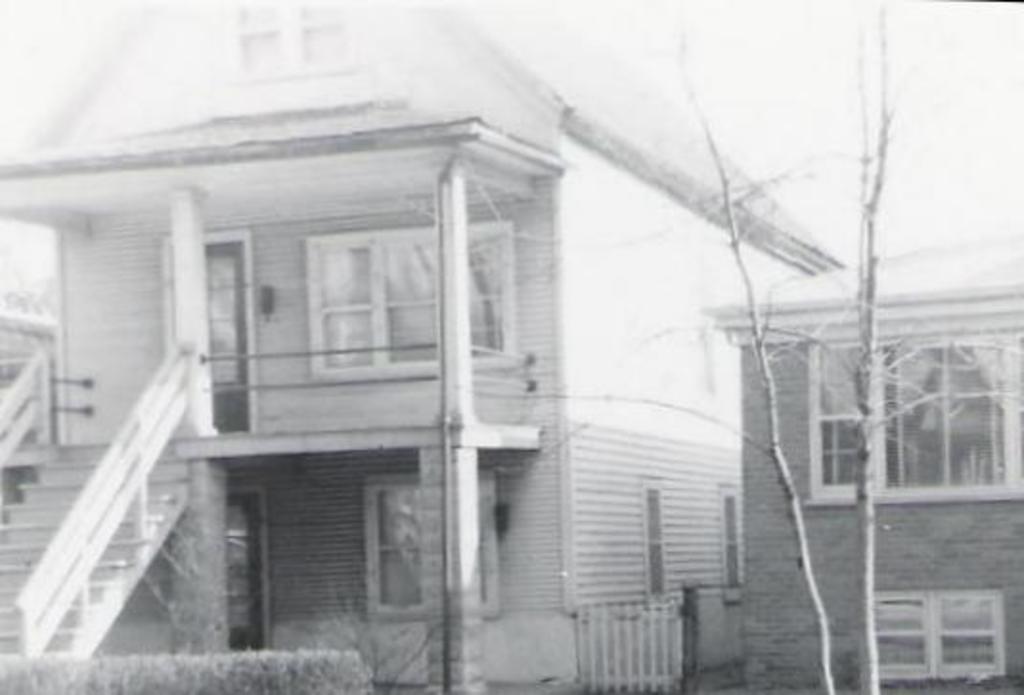In one or two sentences, can you explain what this image depicts? In this picture we can see houses, there is a tree in the front, we can see a door and windows of this house, it is a black and white image, on the left side we can see stairs. 